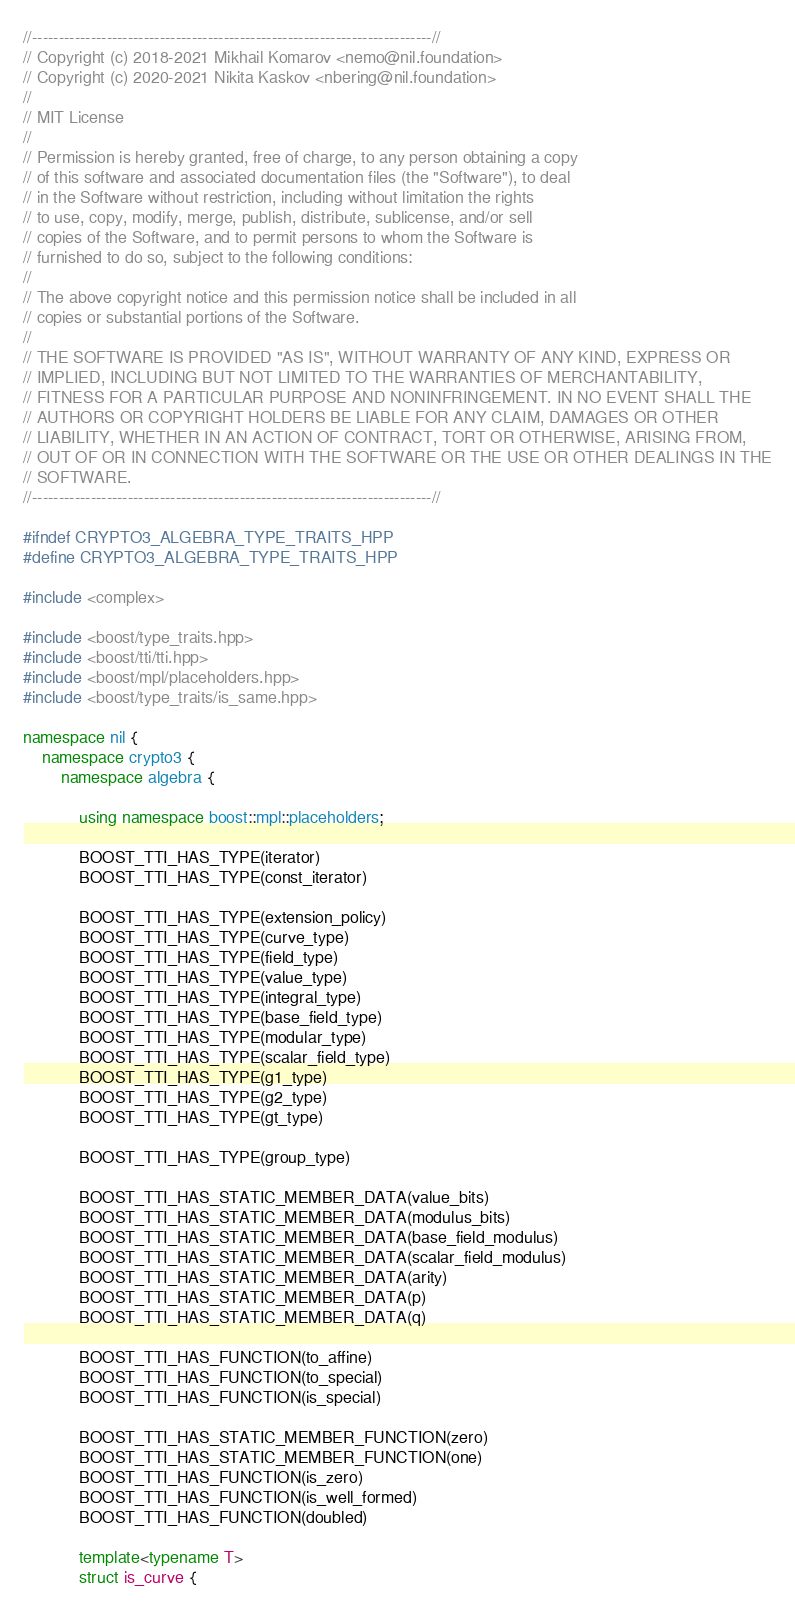<code> <loc_0><loc_0><loc_500><loc_500><_C++_>//---------------------------------------------------------------------------//
// Copyright (c) 2018-2021 Mikhail Komarov <nemo@nil.foundation>
// Copyright (c) 2020-2021 Nikita Kaskov <nbering@nil.foundation>
//
// MIT License
//
// Permission is hereby granted, free of charge, to any person obtaining a copy
// of this software and associated documentation files (the "Software"), to deal
// in the Software without restriction, including without limitation the rights
// to use, copy, modify, merge, publish, distribute, sublicense, and/or sell
// copies of the Software, and to permit persons to whom the Software is
// furnished to do so, subject to the following conditions:
//
// The above copyright notice and this permission notice shall be included in all
// copies or substantial portions of the Software.
//
// THE SOFTWARE IS PROVIDED "AS IS", WITHOUT WARRANTY OF ANY KIND, EXPRESS OR
// IMPLIED, INCLUDING BUT NOT LIMITED TO THE WARRANTIES OF MERCHANTABILITY,
// FITNESS FOR A PARTICULAR PURPOSE AND NONINFRINGEMENT. IN NO EVENT SHALL THE
// AUTHORS OR COPYRIGHT HOLDERS BE LIABLE FOR ANY CLAIM, DAMAGES OR OTHER
// LIABILITY, WHETHER IN AN ACTION OF CONTRACT, TORT OR OTHERWISE, ARISING FROM,
// OUT OF OR IN CONNECTION WITH THE SOFTWARE OR THE USE OR OTHER DEALINGS IN THE
// SOFTWARE.
//---------------------------------------------------------------------------//

#ifndef CRYPTO3_ALGEBRA_TYPE_TRAITS_HPP
#define CRYPTO3_ALGEBRA_TYPE_TRAITS_HPP

#include <complex>

#include <boost/type_traits.hpp>
#include <boost/tti/tti.hpp>
#include <boost/mpl/placeholders.hpp>
#include <boost/type_traits/is_same.hpp>

namespace nil {
    namespace crypto3 {
        namespace algebra {

            using namespace boost::mpl::placeholders;

            BOOST_TTI_HAS_TYPE(iterator)
            BOOST_TTI_HAS_TYPE(const_iterator)

            BOOST_TTI_HAS_TYPE(extension_policy)
            BOOST_TTI_HAS_TYPE(curve_type)
            BOOST_TTI_HAS_TYPE(field_type)
            BOOST_TTI_HAS_TYPE(value_type)
            BOOST_TTI_HAS_TYPE(integral_type)
            BOOST_TTI_HAS_TYPE(base_field_type)
            BOOST_TTI_HAS_TYPE(modular_type)
            BOOST_TTI_HAS_TYPE(scalar_field_type)
            BOOST_TTI_HAS_TYPE(g1_type)
            BOOST_TTI_HAS_TYPE(g2_type)
            BOOST_TTI_HAS_TYPE(gt_type)

            BOOST_TTI_HAS_TYPE(group_type)

            BOOST_TTI_HAS_STATIC_MEMBER_DATA(value_bits)
            BOOST_TTI_HAS_STATIC_MEMBER_DATA(modulus_bits)
            BOOST_TTI_HAS_STATIC_MEMBER_DATA(base_field_modulus)
            BOOST_TTI_HAS_STATIC_MEMBER_DATA(scalar_field_modulus)
            BOOST_TTI_HAS_STATIC_MEMBER_DATA(arity)
            BOOST_TTI_HAS_STATIC_MEMBER_DATA(p)
            BOOST_TTI_HAS_STATIC_MEMBER_DATA(q)

            BOOST_TTI_HAS_FUNCTION(to_affine)
            BOOST_TTI_HAS_FUNCTION(to_special)
            BOOST_TTI_HAS_FUNCTION(is_special)

            BOOST_TTI_HAS_STATIC_MEMBER_FUNCTION(zero)
            BOOST_TTI_HAS_STATIC_MEMBER_FUNCTION(one)
            BOOST_TTI_HAS_FUNCTION(is_zero)
            BOOST_TTI_HAS_FUNCTION(is_well_formed)
            BOOST_TTI_HAS_FUNCTION(doubled)

            template<typename T>
            struct is_curve {</code> 